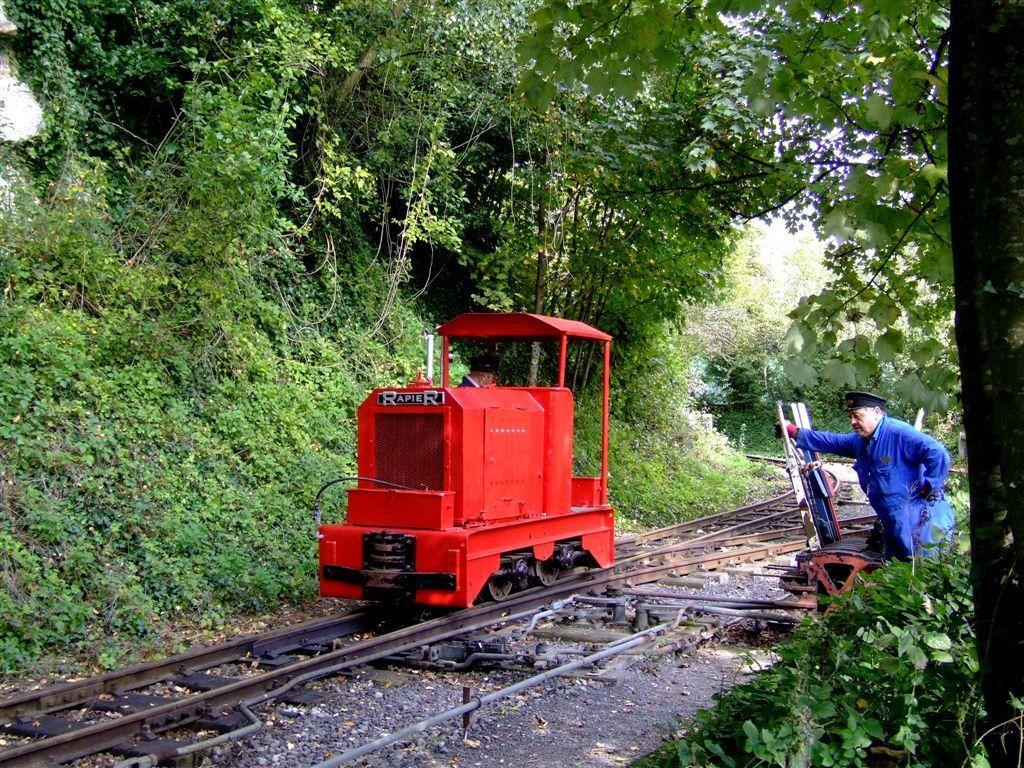Describe this image in one or two sentences. In the center of the image there is a railway speeder on the railway track. On the right there is a man standing. In the background there are trees and we can see plants. 